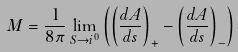Convert formula to latex. <formula><loc_0><loc_0><loc_500><loc_500>M = \frac { 1 } { 8 \pi } \lim _ { S \rightarrow i ^ { 0 } } \left ( \left ( \frac { d A } { d s } \right ) _ { \tt + } - \left ( \frac { d A } { d s } \right ) _ { \tt - } \right )</formula> 